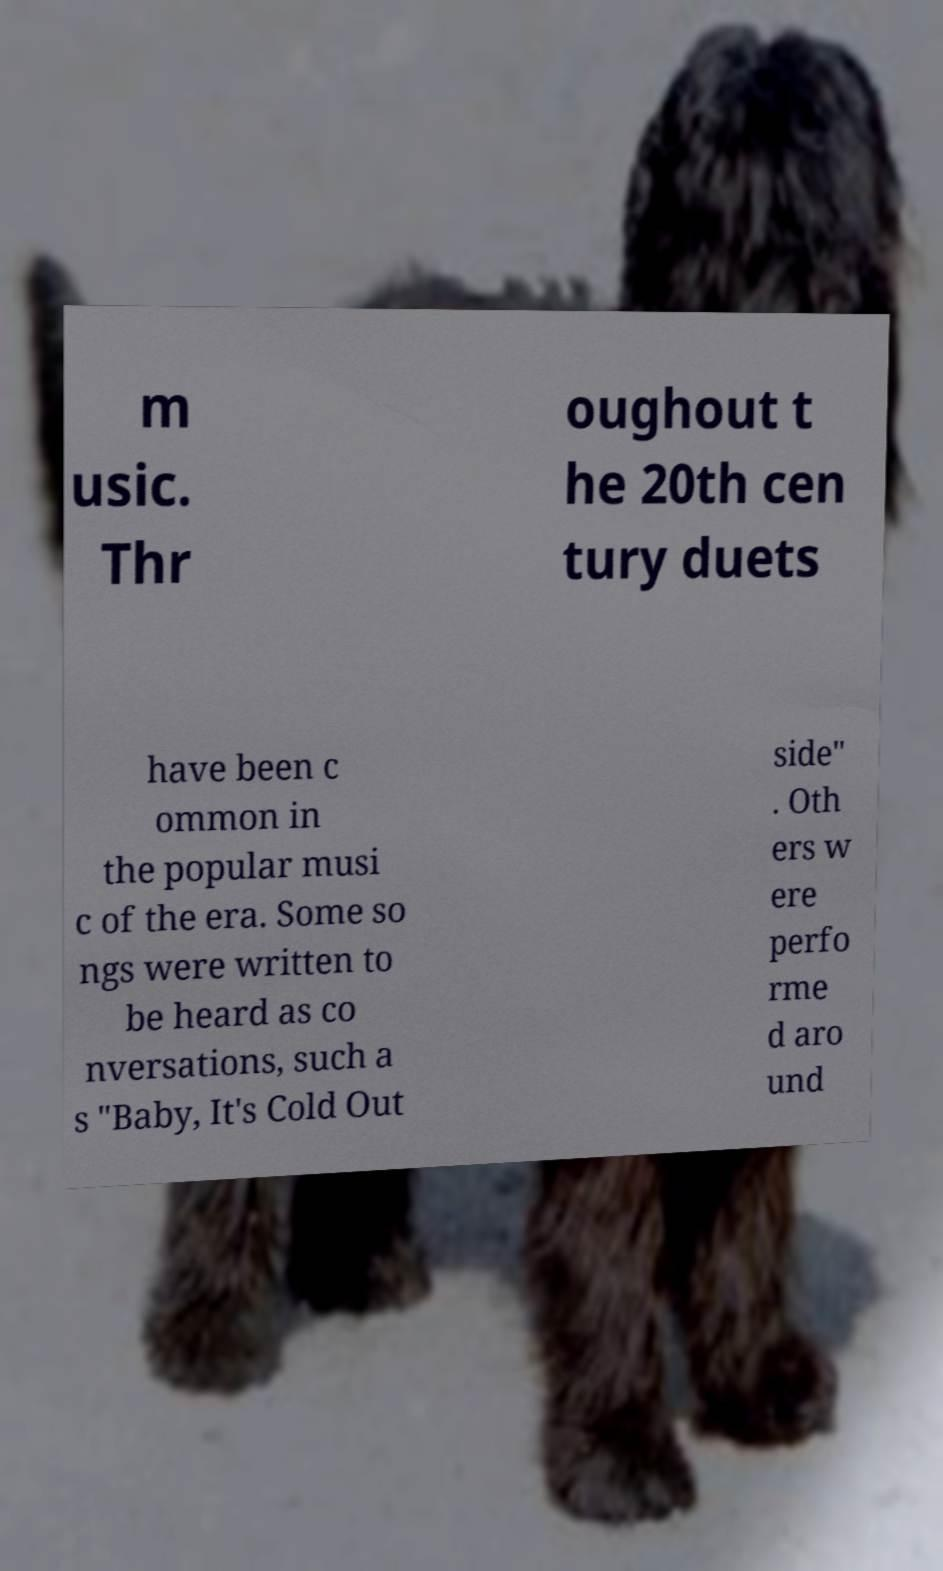Could you assist in decoding the text presented in this image and type it out clearly? m usic. Thr oughout t he 20th cen tury duets have been c ommon in the popular musi c of the era. Some so ngs were written to be heard as co nversations, such a s "Baby, It's Cold Out side" . Oth ers w ere perfo rme d aro und 